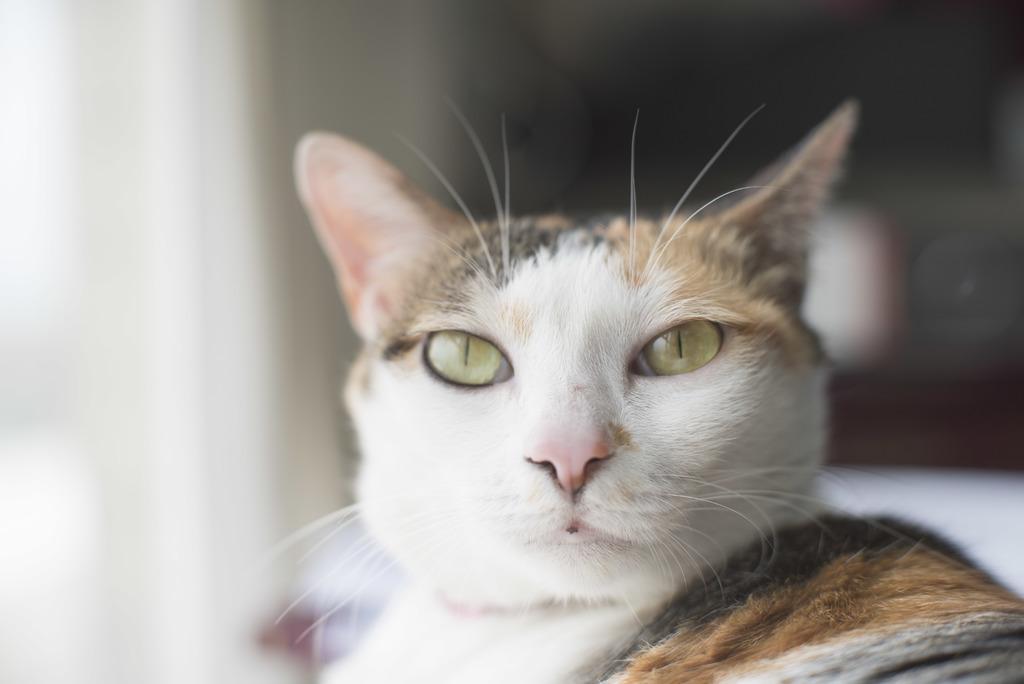Please provide a concise description of this image. In this picture we can see a cat and in the background it is blurry. 